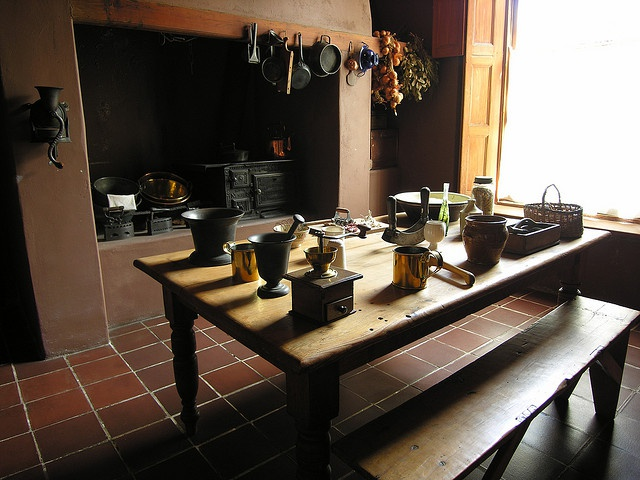Describe the objects in this image and their specific colors. I can see dining table in black, ivory, and maroon tones, bench in black, white, darkgray, and gray tones, oven in black and gray tones, bowl in black, gray, and darkgray tones, and bowl in black, ivory, tan, and darkgreen tones in this image. 